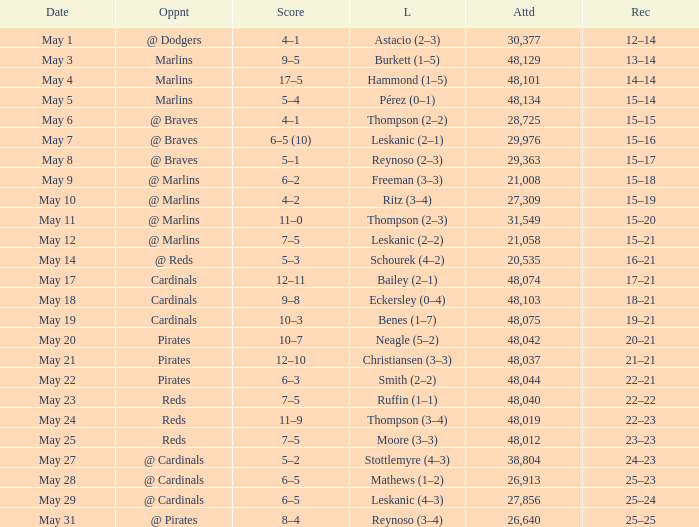Who did the Rockies play at the game that had a score of 6–5 (10)? @ Braves. 